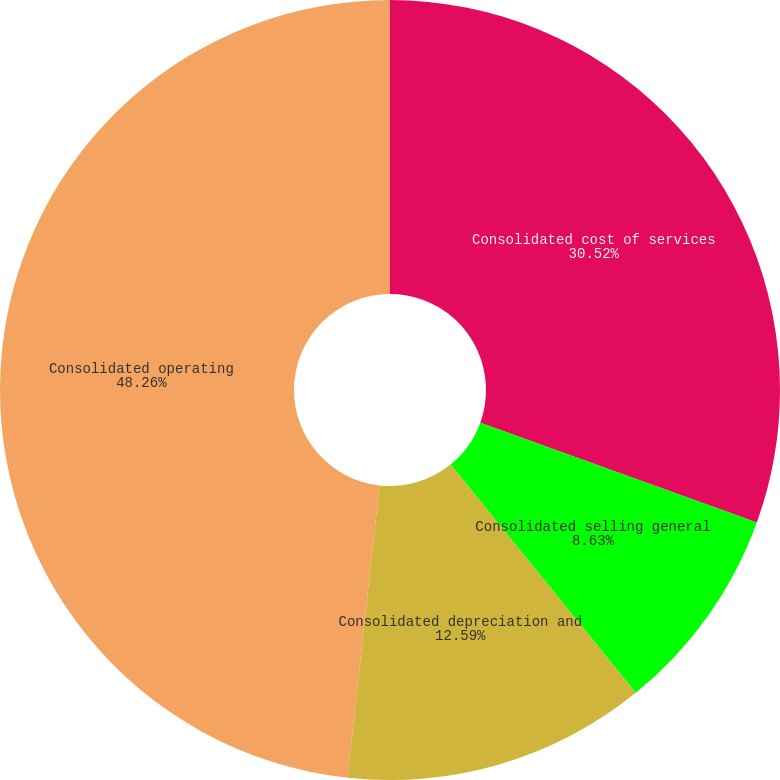Convert chart to OTSL. <chart><loc_0><loc_0><loc_500><loc_500><pie_chart><fcel>Consolidated cost of services<fcel>Consolidated selling general<fcel>Consolidated depreciation and<fcel>Consolidated operating<nl><fcel>30.52%<fcel>8.63%<fcel>12.59%<fcel>48.26%<nl></chart> 